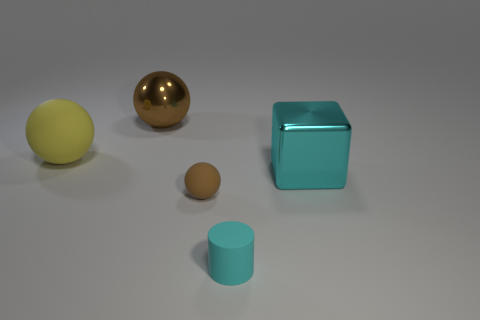Subtract all large balls. How many balls are left? 1 Subtract all cyan cubes. How many brown balls are left? 2 Subtract all yellow balls. How many balls are left? 2 Subtract all cubes. How many objects are left? 4 Add 1 big brown metallic things. How many big brown metallic things exist? 2 Add 1 tiny rubber cubes. How many objects exist? 6 Subtract 0 red cylinders. How many objects are left? 5 Subtract all blue blocks. Subtract all blue balls. How many blocks are left? 1 Subtract all large green metallic balls. Subtract all tiny spheres. How many objects are left? 4 Add 5 cylinders. How many cylinders are left? 6 